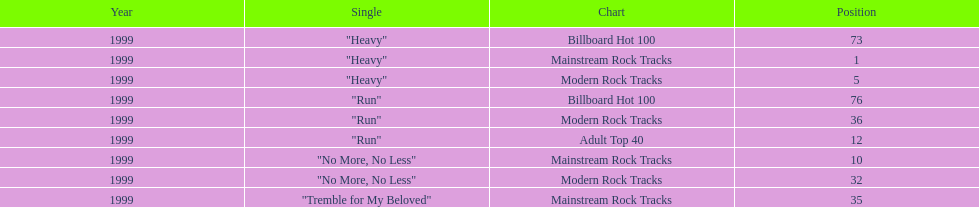How many singles from "dosage" appeared on the modern rock tracks charts? 3. 